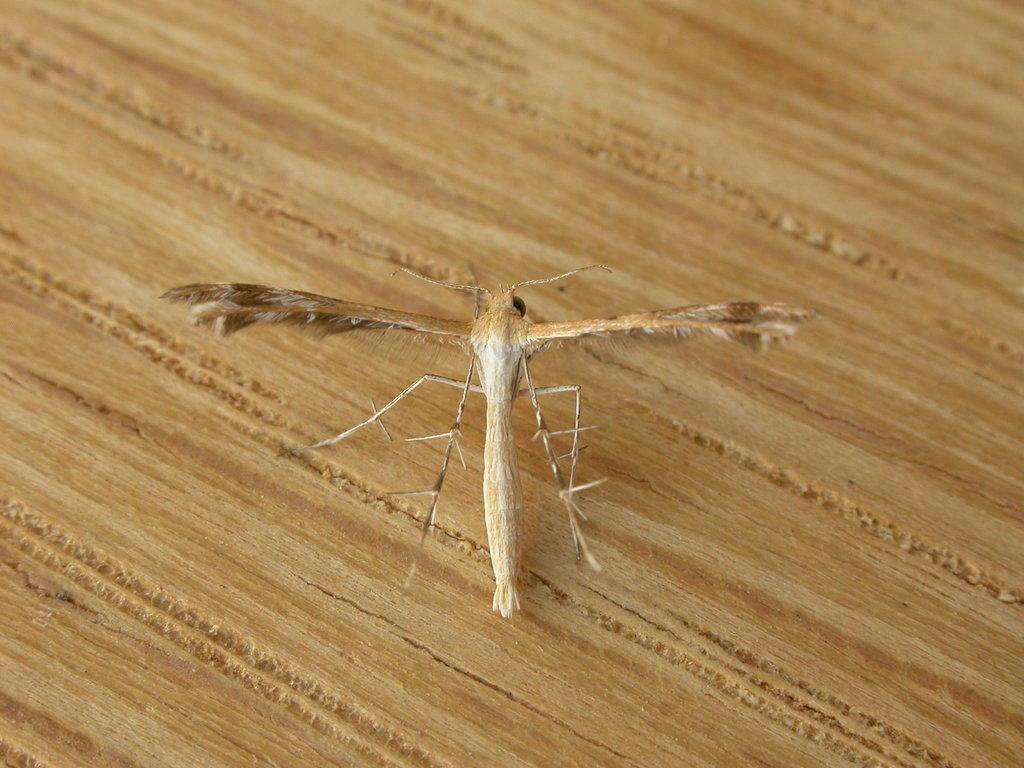In one or two sentences, can you explain what this image depicts? In this picture there is a moth or inset, standing on the table. 